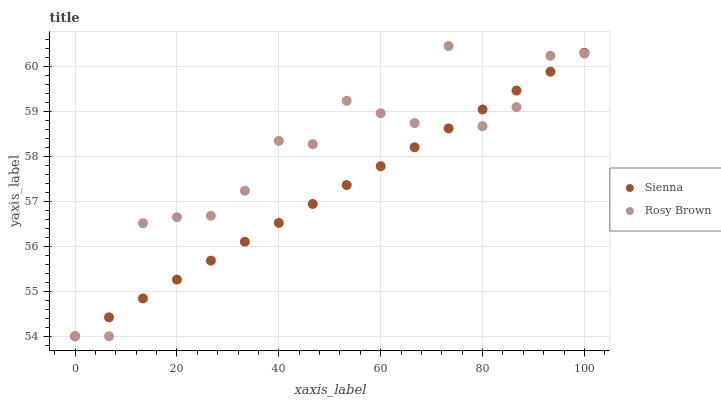Does Sienna have the minimum area under the curve?
Answer yes or no. Yes. Does Rosy Brown have the maximum area under the curve?
Answer yes or no. Yes. Does Rosy Brown have the minimum area under the curve?
Answer yes or no. No. Is Sienna the smoothest?
Answer yes or no. Yes. Is Rosy Brown the roughest?
Answer yes or no. Yes. Is Rosy Brown the smoothest?
Answer yes or no. No. Does Sienna have the lowest value?
Answer yes or no. Yes. Does Rosy Brown have the highest value?
Answer yes or no. Yes. Does Rosy Brown intersect Sienna?
Answer yes or no. Yes. Is Rosy Brown less than Sienna?
Answer yes or no. No. Is Rosy Brown greater than Sienna?
Answer yes or no. No. 